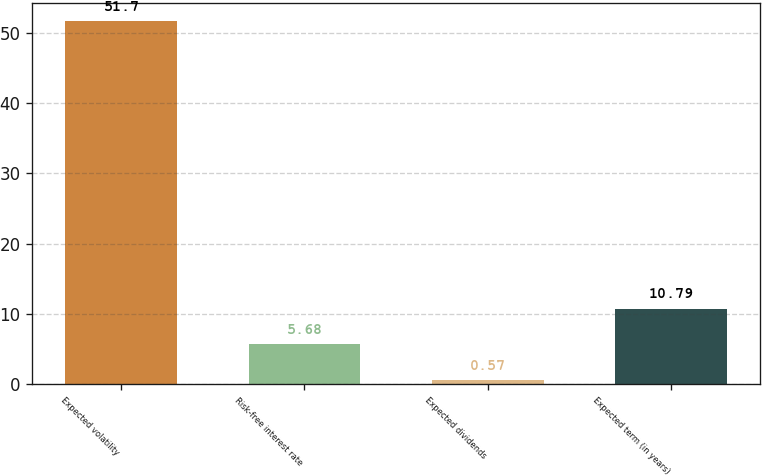Convert chart to OTSL. <chart><loc_0><loc_0><loc_500><loc_500><bar_chart><fcel>Expected volatility<fcel>Risk-free interest rate<fcel>Expected dividends<fcel>Expected term (in years)<nl><fcel>51.7<fcel>5.68<fcel>0.57<fcel>10.79<nl></chart> 